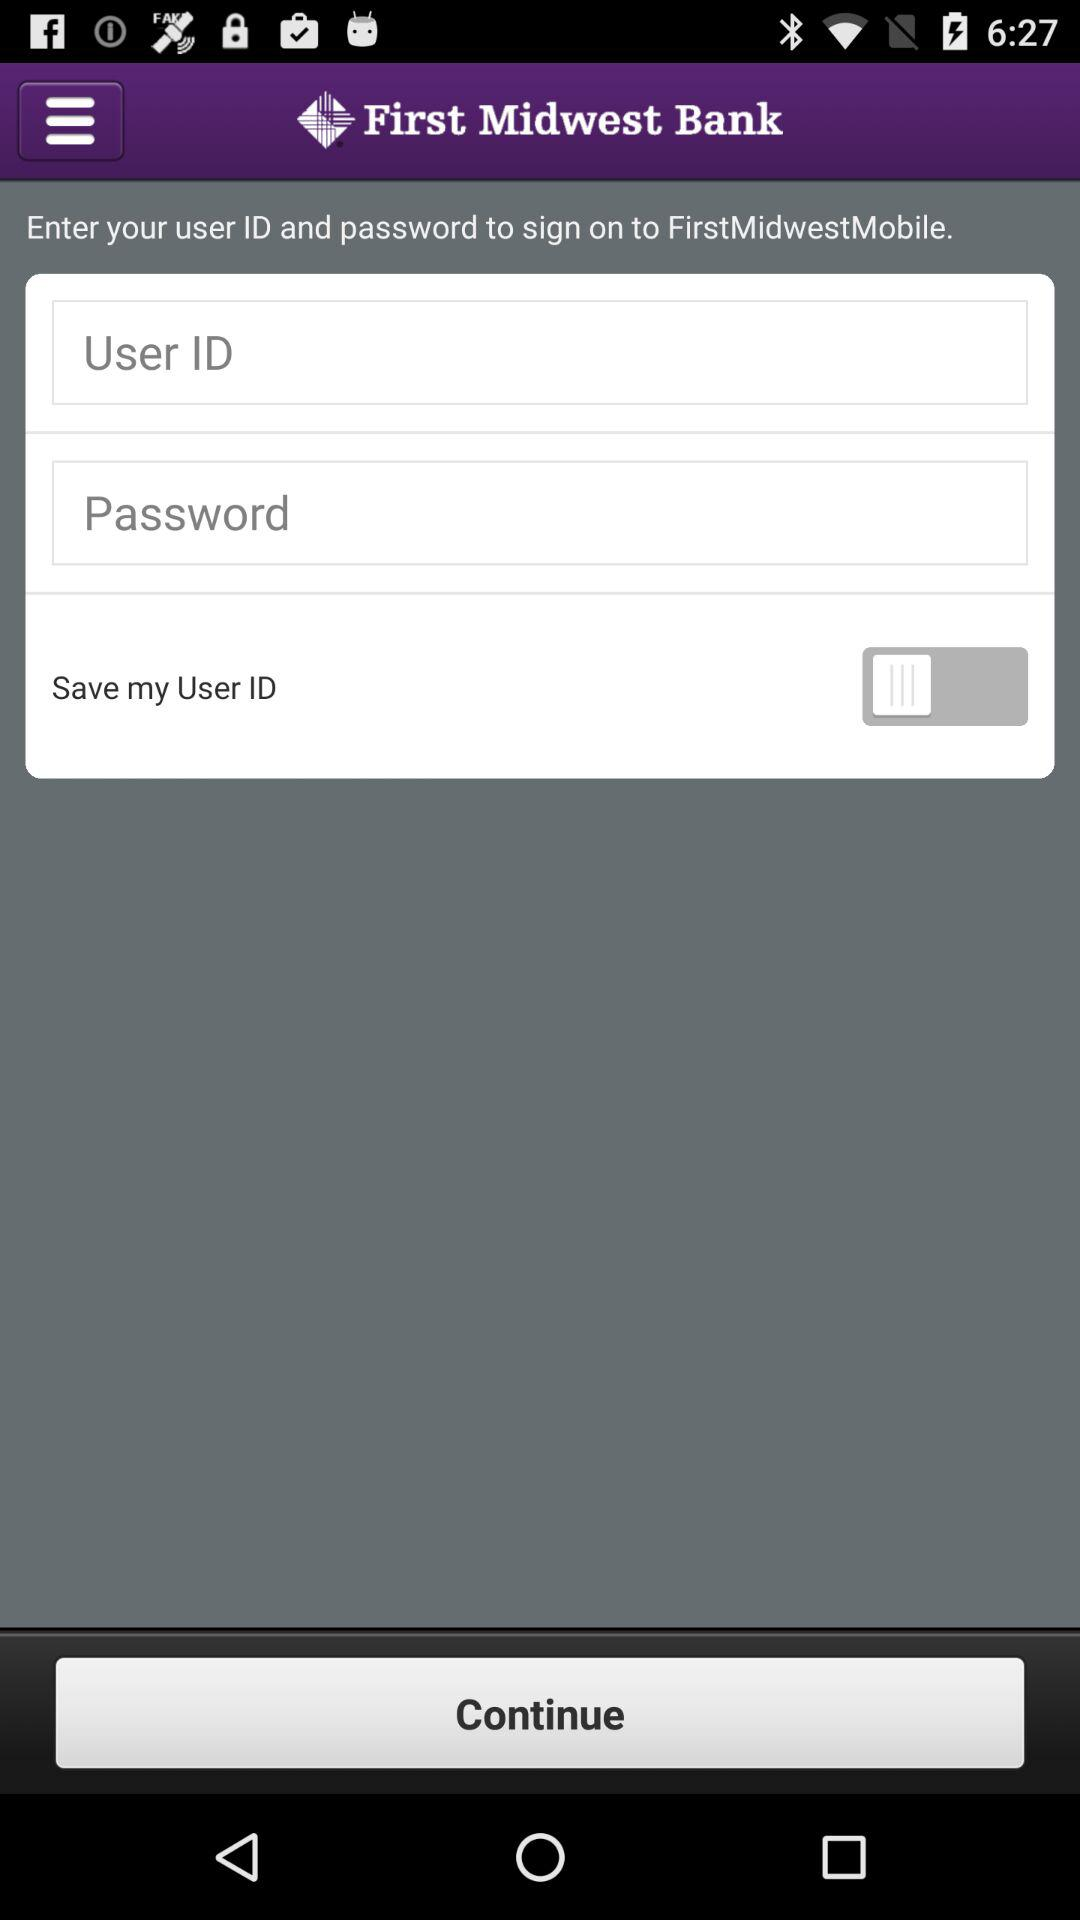What is the status of "Save my User ID"? The status of "Save my User ID" is "off". 